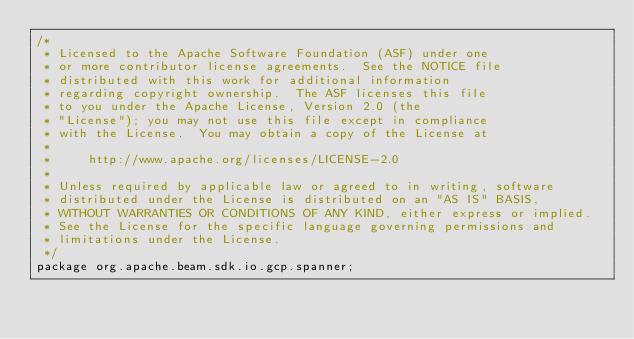<code> <loc_0><loc_0><loc_500><loc_500><_Java_>/*
 * Licensed to the Apache Software Foundation (ASF) under one
 * or more contributor license agreements.  See the NOTICE file
 * distributed with this work for additional information
 * regarding copyright ownership.  The ASF licenses this file
 * to you under the Apache License, Version 2.0 (the
 * "License"); you may not use this file except in compliance
 * with the License.  You may obtain a copy of the License at
 *
 *     http://www.apache.org/licenses/LICENSE-2.0
 *
 * Unless required by applicable law or agreed to in writing, software
 * distributed under the License is distributed on an "AS IS" BASIS,
 * WITHOUT WARRANTIES OR CONDITIONS OF ANY KIND, either express or implied.
 * See the License for the specific language governing permissions and
 * limitations under the License.
 */
package org.apache.beam.sdk.io.gcp.spanner;
</code> 